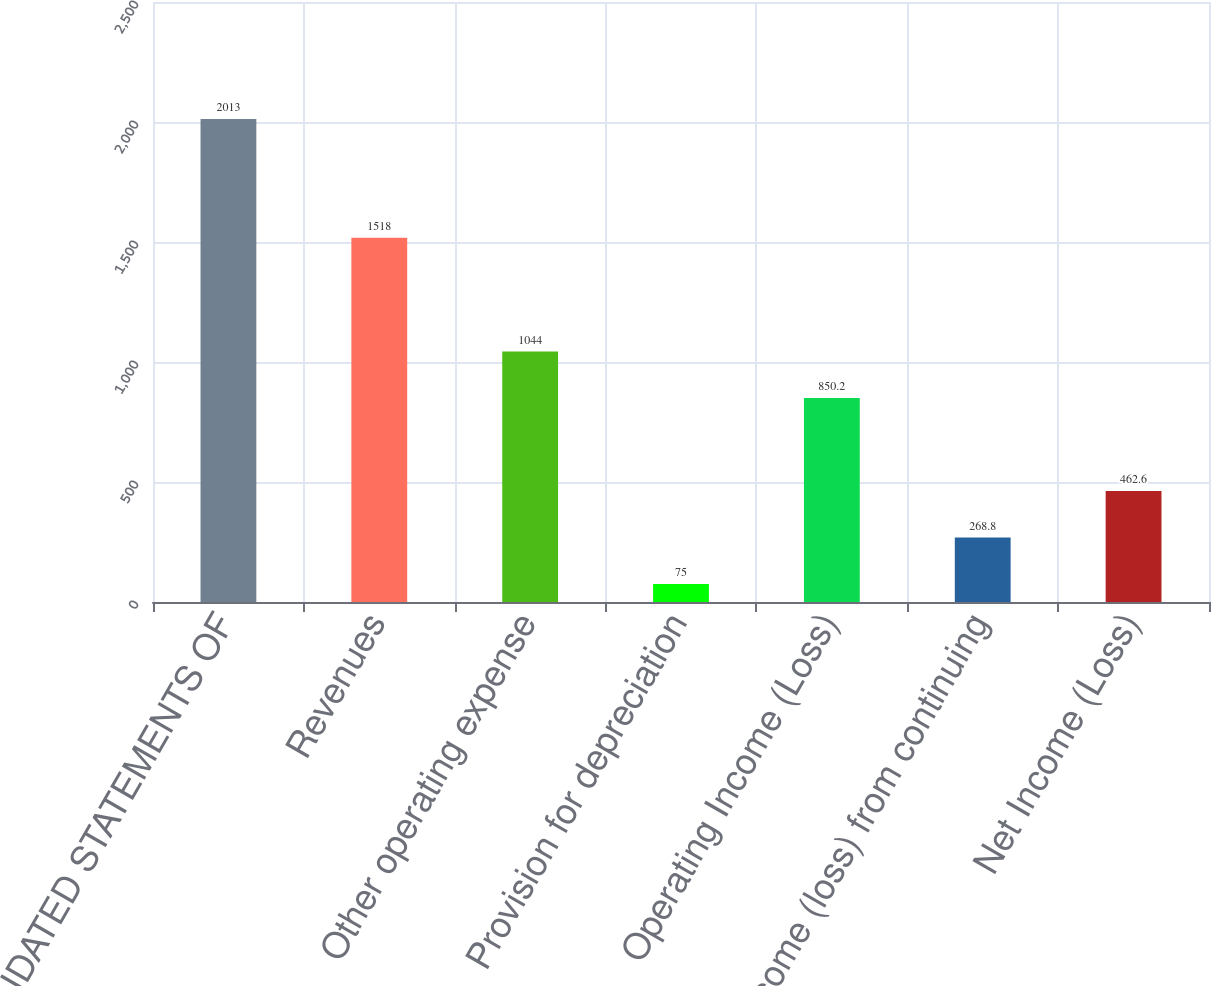<chart> <loc_0><loc_0><loc_500><loc_500><bar_chart><fcel>CONSOLIDATED STATEMENTS OF<fcel>Revenues<fcel>Other operating expense<fcel>Provision for depreciation<fcel>Operating Income (Loss)<fcel>Income (loss) from continuing<fcel>Net Income (Loss)<nl><fcel>2013<fcel>1518<fcel>1044<fcel>75<fcel>850.2<fcel>268.8<fcel>462.6<nl></chart> 